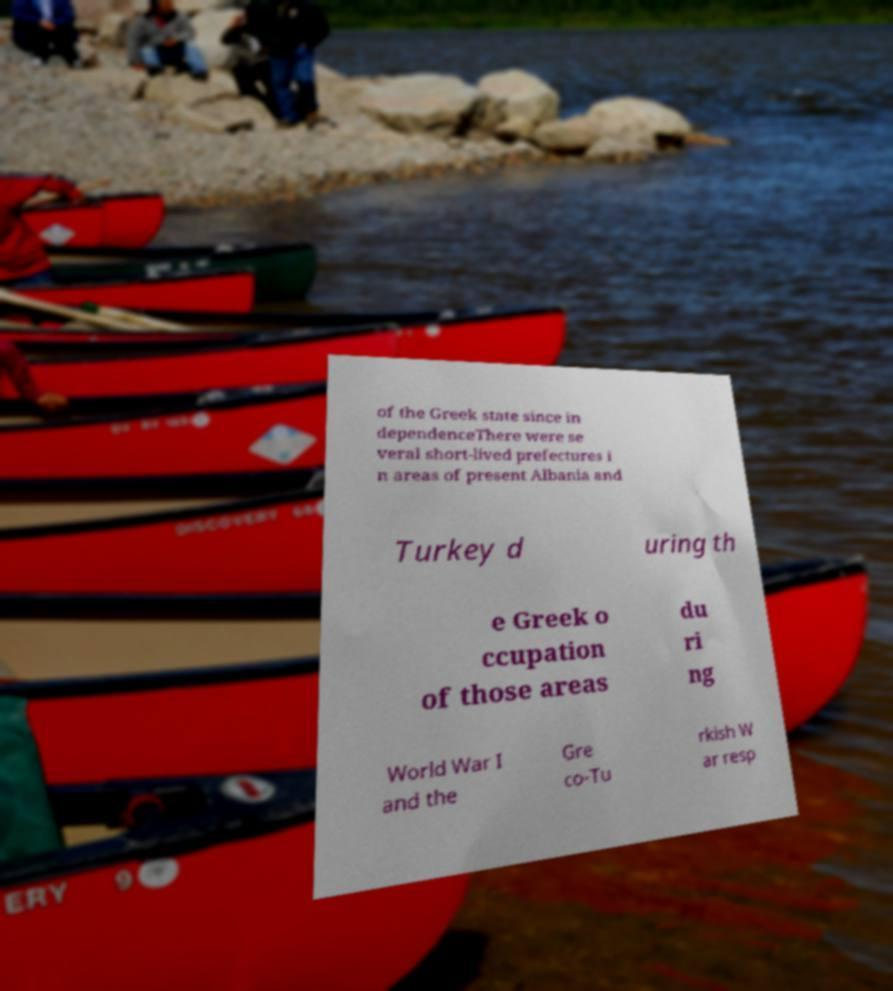Please identify and transcribe the text found in this image. of the Greek state since in dependenceThere were se veral short-lived prefectures i n areas of present Albania and Turkey d uring th e Greek o ccupation of those areas du ri ng World War I and the Gre co-Tu rkish W ar resp 